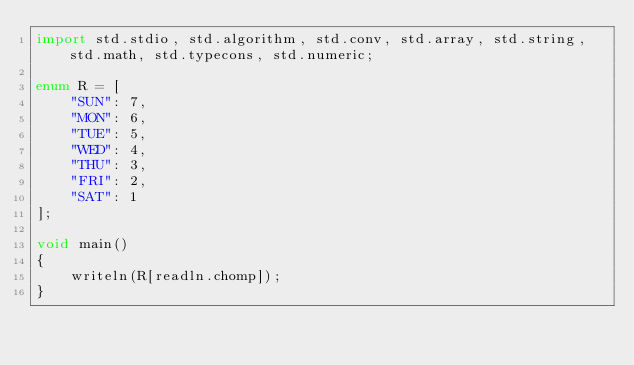Convert code to text. <code><loc_0><loc_0><loc_500><loc_500><_D_>import std.stdio, std.algorithm, std.conv, std.array, std.string, std.math, std.typecons, std.numeric;

enum R = [
    "SUN": 7,
    "MON": 6,
    "TUE": 5,
    "WED": 4,
    "THU": 3,
    "FRI": 2,
    "SAT": 1
];

void main()
{
    writeln(R[readln.chomp]);
}</code> 